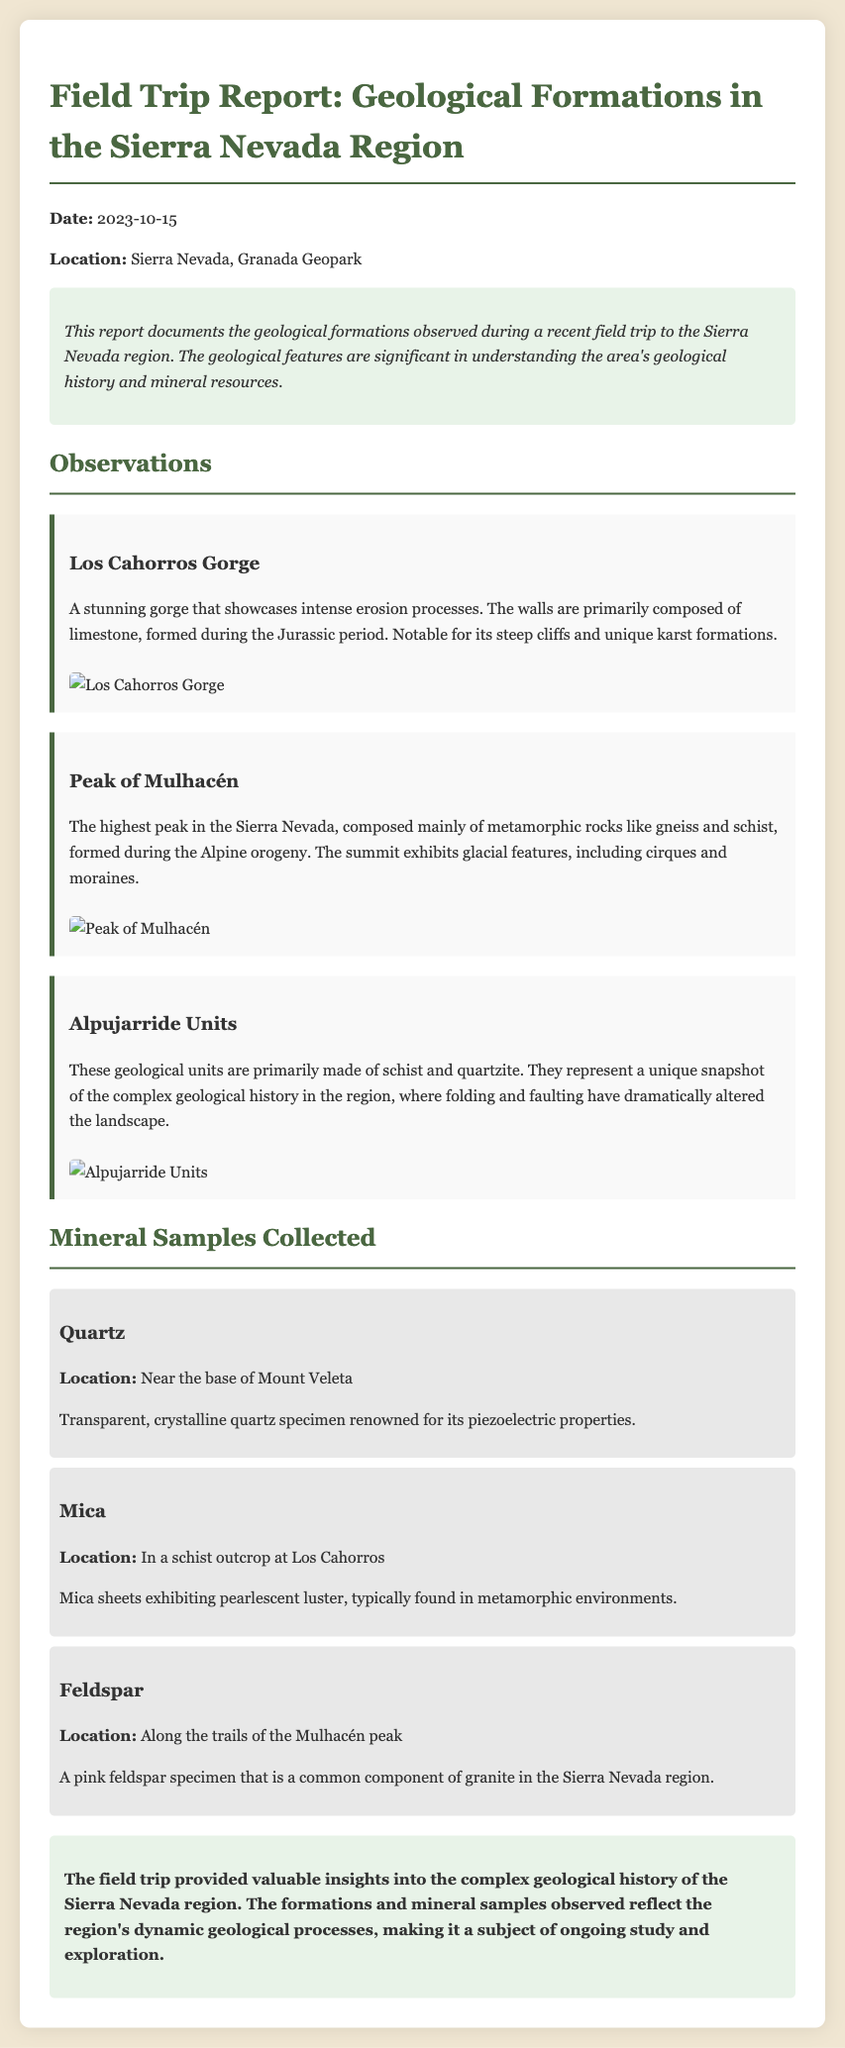What is the date of the field trip? The date of the field trip is mentioned at the beginning of the report.
Answer: 2023-10-15 Where was the field trip conducted? The location of the field trip is specified just after the date in the report.
Answer: Sierra Nevada, Granada Geopark What type of rock primarily composes the Peak of Mulhacén? The report describes the rocks found at the Peak of Mulhacén specifically, noting their type.
Answer: Metamorphic rocks What mineral was collected near the base of Mount Veleta? The report lists the mineral samples collected along with their respective locations.
Answer: Quartz Which geological feature exhibits glacial features? The observation section describes features associated with the geological formations, including those exhibiting glacial characteristics.
Answer: Peak of Mulhacén What are the main components of the Alpujarride Units? The report outlines the composition of the Alpujarride Units, providing details on their geological makeup.
Answer: Schist and quartzite How many mineral samples were collected during the trip? The report details the mineral samples, allowing for a count to be made from the section listed.
Answer: Three What is notable about the granite feldspar specimen? The report includes specific characteristics of each mineral sample, including a notable property.
Answer: Pink feldspar specimen What does the conclusion of the report emphasize? The conclusion summarizes the insights gained from the field trip regarding geological history.
Answer: Ongoing study and exploration 